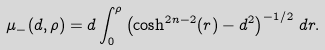<formula> <loc_0><loc_0><loc_500><loc_500>\mu _ { - } ( d , \rho ) = d \int _ { 0 } ^ { \rho } \left ( \cosh ^ { 2 n - 2 } ( r ) - d ^ { 2 } \right ) ^ { - 1 / 2 } \, d r .</formula> 